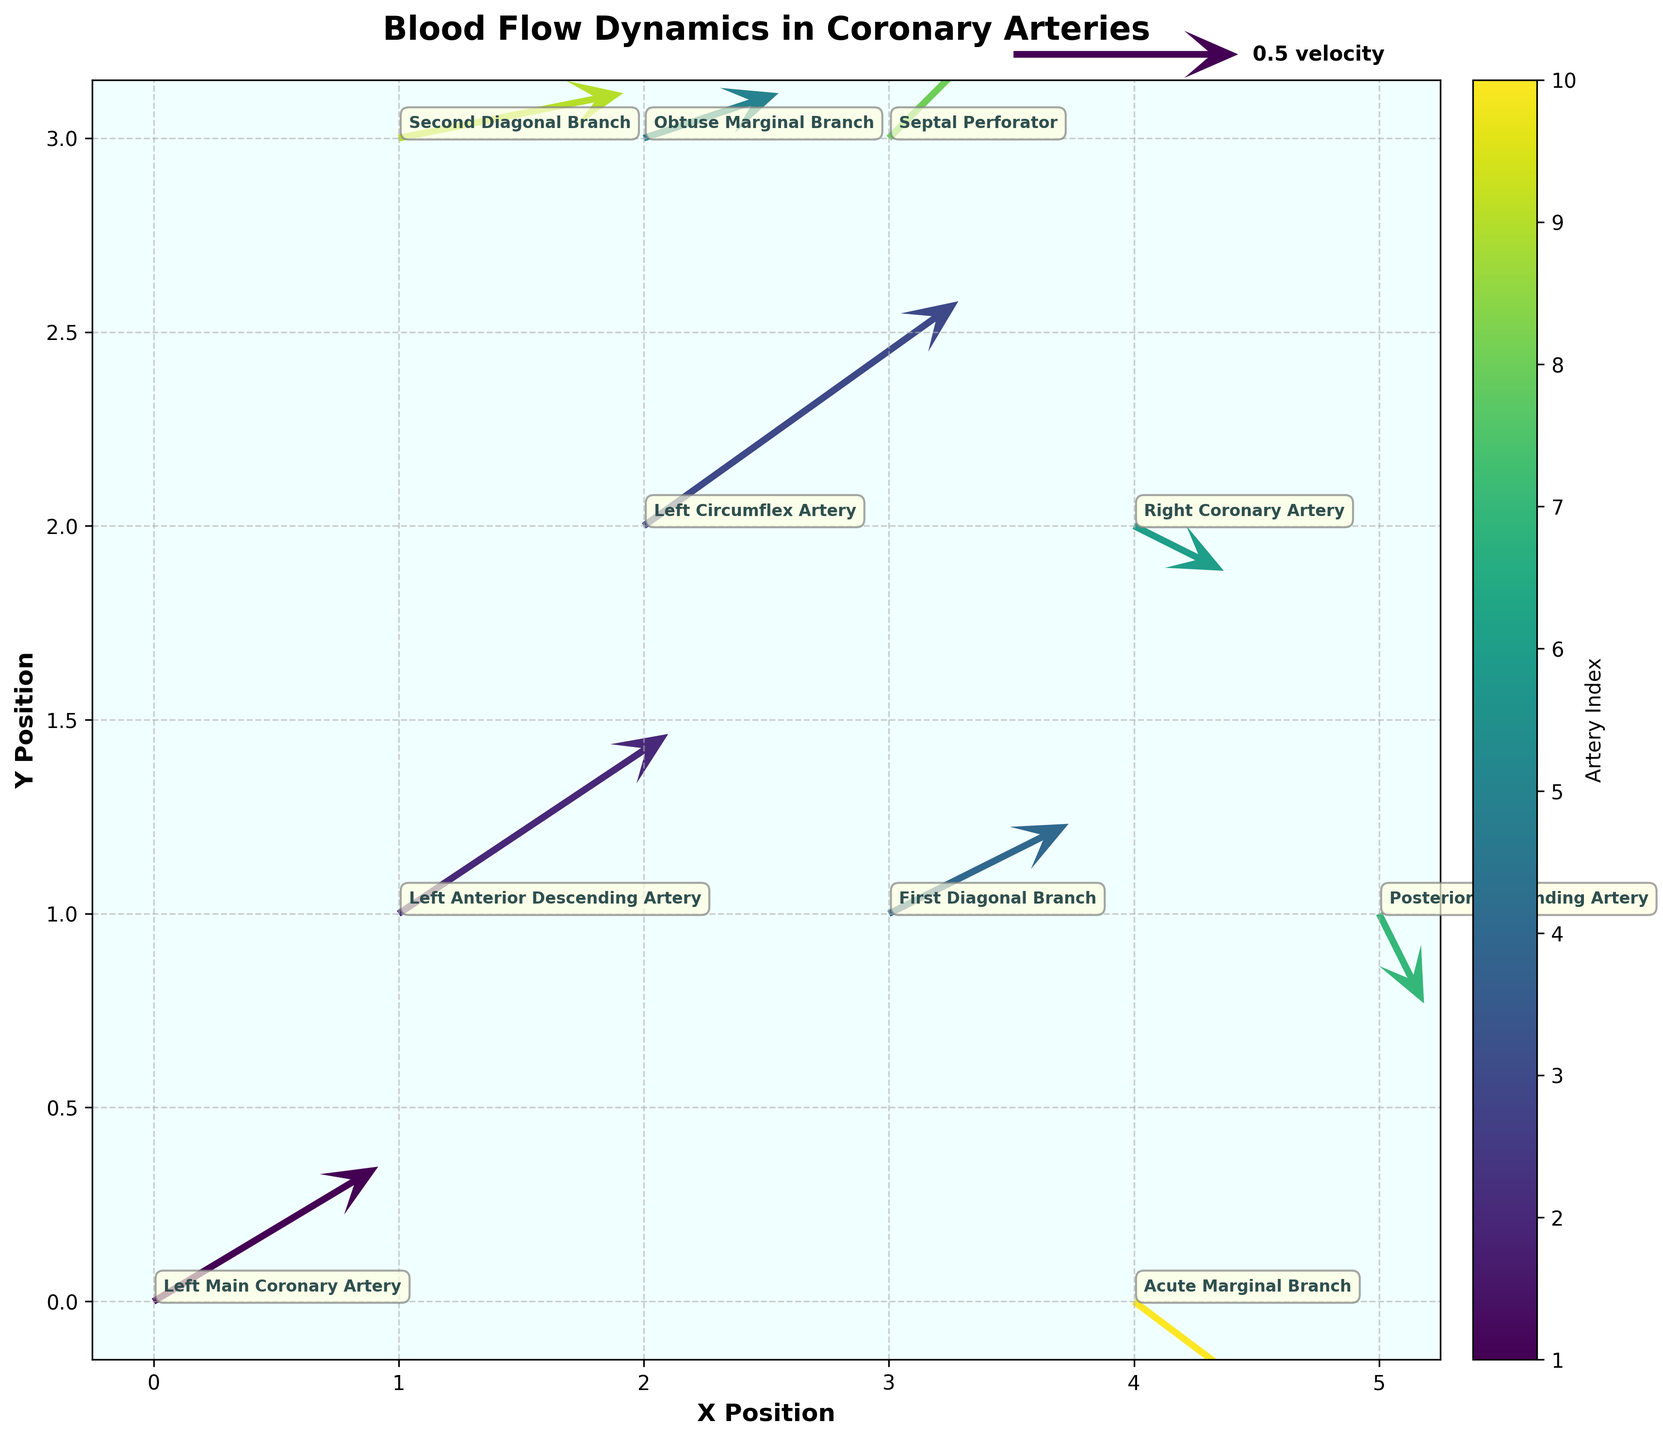What information is displayed in the plot's title? The title of the plot provides a concise description of what the figure is illustrating. To identify it, look at the text at the top of the figure. It usually summarizes the main topic or data being visualized.
Answer: Blood Flow Dynamics in Coronary Arteries What is the position of the Right Coronary Artery on the plot? Locate the label "Right Coronary Artery" on the plot to find the x and y coordinates associated with it. Check the annotated point and read off the coordinates from the axis.
Answer: (4, 2) How many arteries are visualized in the plot? Count the labels indicated for different arteries in the plot. Each label corresponds to a unique artery.
Answer: 10 Which artery has the highest velocity component in the x-direction? Examine the u-component of each vector. Compare the u-values to identify the artery with the maximum value. The Left Circumflex Artery has a u value of 0.7, which is the highest.
Answer: Left Circumflex Artery What are the x and y velocity components for the Posterior Descending Artery? Find the Posterior Descending Artery’s vector in the plot. Check the components of the vector attached to this artery.
Answer: (0.1, -0.2) Which artery shows a negative velocity component in the y-direction? Identify the vectors with a negative v-component. The arrows pointing downwards indicate a negative v-component. The Right Coronary Artery and Posterior Descending Artery have negative v-components.
Answer: Right Coronary Artery, Posterior Descending Artery What is the average x-coordinate of the arteries? Add the x-coordinates for all listed arteries and divide by the number of arteries. The sum of the x-coordinates is 25. Dividing by the number of arteries (10) results in an average of 2.5.
Answer: 2.5 Compare the velocity hypotenuses of the Left Main Coronary Artery and Second Diagonal Branch. Which one is greater? Calculate the hypotenuse of each velocity vector using the Pythagorean theorem. For the Left Main Coronary Artery, sqrt(0.5^2 + 0.3^2) = sqrt(0.34) ≈ 0.583. For the Second Diagonal Branch, sqrt(0.5^2 + 0.1^2) = sqrt(0.26) ≈ 0.510. The Left Main Coronary Artery has a greater hypotenuse.
Answer: Left Main Coronary Artery What is the angle of the velocity vector of the Acute Marginal Branch with respect to the x-axis? Use the arctangent function to calculate the angle: arctan(v/u). For the Acute Marginal Branch, it is arctan(-0.3/0.4) ≈ -36.87 degrees.
Answer: -36.87 degrees How is the color mapped for the quiver arrows? Observe the color gradient on the plot and the provided color bar. The colors are mapped using the 'viridis' colormap, which gradually changes from one color to another based on artery index.
Answer: Using 'viridis' colormap 